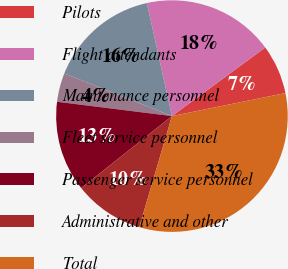Convert chart to OTSL. <chart><loc_0><loc_0><loc_500><loc_500><pie_chart><fcel>Pilots<fcel>Flight attendants<fcel>Maintenance personnel<fcel>Fleet service personnel<fcel>Passenger service personnel<fcel>Administrative and other<fcel>Total<nl><fcel>6.9%<fcel>18.39%<fcel>15.52%<fcel>4.03%<fcel>12.65%<fcel>9.77%<fcel>32.74%<nl></chart> 